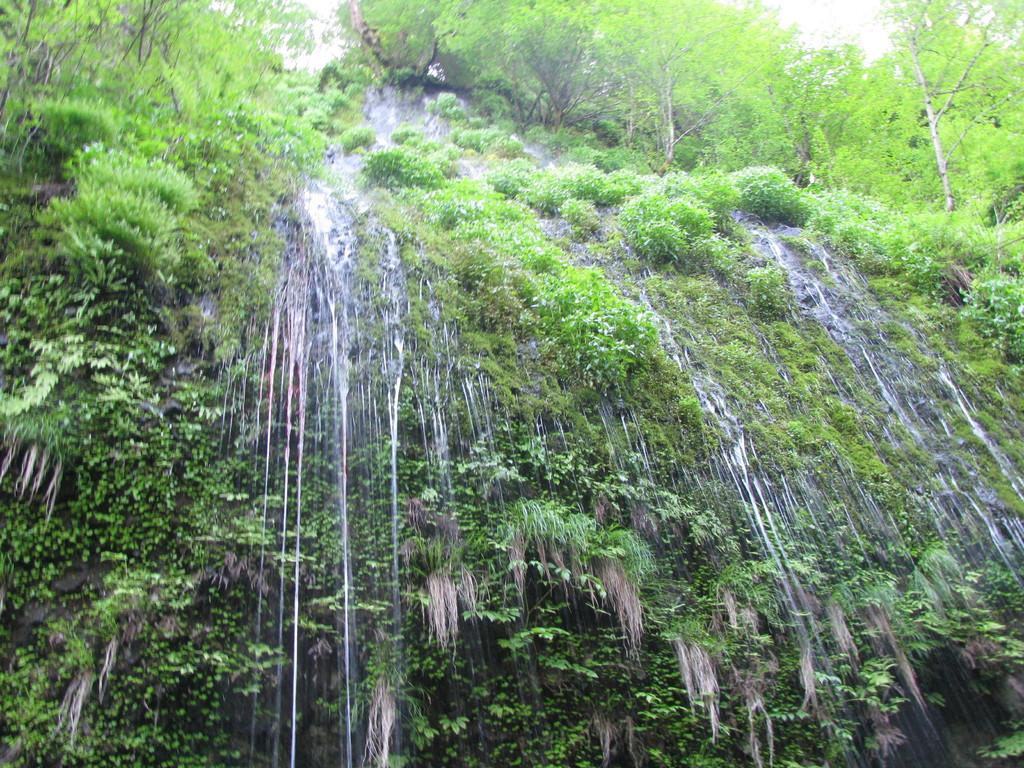What natural feature is the main subject of the picture? There is a waterfall in the picture. What type of vegetation can be seen on the hills in the picture? There are trees on the hills in the picture. What type of rub is being used to clean the waterfall in the image? There is no rub or cleaning activity depicted in the image; it simply shows a waterfall and trees on the hills. 